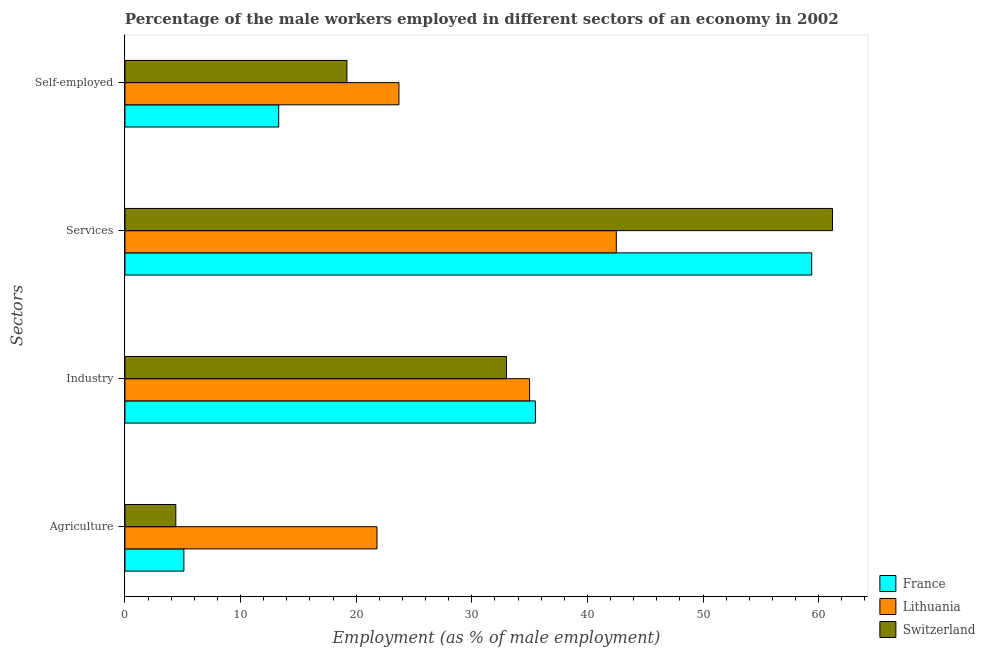How many different coloured bars are there?
Your answer should be very brief. 3. How many groups of bars are there?
Provide a short and direct response. 4. Are the number of bars per tick equal to the number of legend labels?
Keep it short and to the point. Yes. How many bars are there on the 4th tick from the top?
Offer a terse response. 3. How many bars are there on the 1st tick from the bottom?
Provide a succinct answer. 3. What is the label of the 2nd group of bars from the top?
Offer a very short reply. Services. Across all countries, what is the maximum percentage of male workers in services?
Ensure brevity in your answer.  61.2. Across all countries, what is the minimum percentage of male workers in industry?
Your answer should be very brief. 33. In which country was the percentage of male workers in industry maximum?
Make the answer very short. France. In which country was the percentage of male workers in agriculture minimum?
Ensure brevity in your answer.  Switzerland. What is the total percentage of self employed male workers in the graph?
Your answer should be compact. 56.2. What is the difference between the percentage of male workers in agriculture in France and that in Lithuania?
Your response must be concise. -16.7. What is the difference between the percentage of male workers in services in Lithuania and the percentage of self employed male workers in France?
Your answer should be very brief. 29.2. What is the average percentage of self employed male workers per country?
Provide a succinct answer. 18.73. What is the difference between the percentage of male workers in services and percentage of male workers in industry in France?
Make the answer very short. 23.9. What is the ratio of the percentage of self employed male workers in France to that in Switzerland?
Your response must be concise. 0.69. Is the percentage of self employed male workers in Switzerland less than that in France?
Make the answer very short. No. What is the difference between the highest and the second highest percentage of self employed male workers?
Your answer should be compact. 4.5. What is the difference between the highest and the lowest percentage of male workers in agriculture?
Provide a succinct answer. 17.4. In how many countries, is the percentage of male workers in services greater than the average percentage of male workers in services taken over all countries?
Make the answer very short. 2. Is the sum of the percentage of self employed male workers in Switzerland and France greater than the maximum percentage of male workers in industry across all countries?
Ensure brevity in your answer.  No. Is it the case that in every country, the sum of the percentage of self employed male workers and percentage of male workers in agriculture is greater than the sum of percentage of male workers in services and percentage of male workers in industry?
Offer a terse response. No. What does the 2nd bar from the top in Self-employed represents?
Give a very brief answer. Lithuania. How many bars are there?
Offer a terse response. 12. Are all the bars in the graph horizontal?
Keep it short and to the point. Yes. Does the graph contain grids?
Ensure brevity in your answer.  No. Where does the legend appear in the graph?
Offer a very short reply. Bottom right. How many legend labels are there?
Your answer should be very brief. 3. How are the legend labels stacked?
Ensure brevity in your answer.  Vertical. What is the title of the graph?
Your answer should be very brief. Percentage of the male workers employed in different sectors of an economy in 2002. Does "Lower middle income" appear as one of the legend labels in the graph?
Provide a succinct answer. No. What is the label or title of the X-axis?
Your response must be concise. Employment (as % of male employment). What is the label or title of the Y-axis?
Give a very brief answer. Sectors. What is the Employment (as % of male employment) in France in Agriculture?
Your answer should be compact. 5.1. What is the Employment (as % of male employment) in Lithuania in Agriculture?
Provide a short and direct response. 21.8. What is the Employment (as % of male employment) in Switzerland in Agriculture?
Your response must be concise. 4.4. What is the Employment (as % of male employment) of France in Industry?
Give a very brief answer. 35.5. What is the Employment (as % of male employment) of Lithuania in Industry?
Ensure brevity in your answer.  35. What is the Employment (as % of male employment) of France in Services?
Make the answer very short. 59.4. What is the Employment (as % of male employment) of Lithuania in Services?
Your answer should be compact. 42.5. What is the Employment (as % of male employment) in Switzerland in Services?
Offer a very short reply. 61.2. What is the Employment (as % of male employment) of France in Self-employed?
Offer a very short reply. 13.3. What is the Employment (as % of male employment) in Lithuania in Self-employed?
Offer a very short reply. 23.7. What is the Employment (as % of male employment) in Switzerland in Self-employed?
Ensure brevity in your answer.  19.2. Across all Sectors, what is the maximum Employment (as % of male employment) of France?
Provide a succinct answer. 59.4. Across all Sectors, what is the maximum Employment (as % of male employment) in Lithuania?
Your answer should be compact. 42.5. Across all Sectors, what is the maximum Employment (as % of male employment) in Switzerland?
Ensure brevity in your answer.  61.2. Across all Sectors, what is the minimum Employment (as % of male employment) in France?
Ensure brevity in your answer.  5.1. Across all Sectors, what is the minimum Employment (as % of male employment) in Lithuania?
Provide a short and direct response. 21.8. Across all Sectors, what is the minimum Employment (as % of male employment) of Switzerland?
Make the answer very short. 4.4. What is the total Employment (as % of male employment) in France in the graph?
Provide a short and direct response. 113.3. What is the total Employment (as % of male employment) of Lithuania in the graph?
Your answer should be compact. 123. What is the total Employment (as % of male employment) in Switzerland in the graph?
Ensure brevity in your answer.  117.8. What is the difference between the Employment (as % of male employment) of France in Agriculture and that in Industry?
Ensure brevity in your answer.  -30.4. What is the difference between the Employment (as % of male employment) in Lithuania in Agriculture and that in Industry?
Your response must be concise. -13.2. What is the difference between the Employment (as % of male employment) in Switzerland in Agriculture and that in Industry?
Provide a succinct answer. -28.6. What is the difference between the Employment (as % of male employment) of France in Agriculture and that in Services?
Your answer should be very brief. -54.3. What is the difference between the Employment (as % of male employment) in Lithuania in Agriculture and that in Services?
Your answer should be compact. -20.7. What is the difference between the Employment (as % of male employment) of Switzerland in Agriculture and that in Services?
Keep it short and to the point. -56.8. What is the difference between the Employment (as % of male employment) in France in Agriculture and that in Self-employed?
Provide a succinct answer. -8.2. What is the difference between the Employment (as % of male employment) of Lithuania in Agriculture and that in Self-employed?
Offer a very short reply. -1.9. What is the difference between the Employment (as % of male employment) in Switzerland in Agriculture and that in Self-employed?
Provide a short and direct response. -14.8. What is the difference between the Employment (as % of male employment) of France in Industry and that in Services?
Offer a terse response. -23.9. What is the difference between the Employment (as % of male employment) of Switzerland in Industry and that in Services?
Your response must be concise. -28.2. What is the difference between the Employment (as % of male employment) in Lithuania in Industry and that in Self-employed?
Your response must be concise. 11.3. What is the difference between the Employment (as % of male employment) of Switzerland in Industry and that in Self-employed?
Ensure brevity in your answer.  13.8. What is the difference between the Employment (as % of male employment) of France in Services and that in Self-employed?
Keep it short and to the point. 46.1. What is the difference between the Employment (as % of male employment) in France in Agriculture and the Employment (as % of male employment) in Lithuania in Industry?
Your answer should be very brief. -29.9. What is the difference between the Employment (as % of male employment) of France in Agriculture and the Employment (as % of male employment) of Switzerland in Industry?
Offer a terse response. -27.9. What is the difference between the Employment (as % of male employment) in France in Agriculture and the Employment (as % of male employment) in Lithuania in Services?
Your answer should be very brief. -37.4. What is the difference between the Employment (as % of male employment) of France in Agriculture and the Employment (as % of male employment) of Switzerland in Services?
Provide a short and direct response. -56.1. What is the difference between the Employment (as % of male employment) in Lithuania in Agriculture and the Employment (as % of male employment) in Switzerland in Services?
Your answer should be very brief. -39.4. What is the difference between the Employment (as % of male employment) in France in Agriculture and the Employment (as % of male employment) in Lithuania in Self-employed?
Your response must be concise. -18.6. What is the difference between the Employment (as % of male employment) of France in Agriculture and the Employment (as % of male employment) of Switzerland in Self-employed?
Offer a very short reply. -14.1. What is the difference between the Employment (as % of male employment) of France in Industry and the Employment (as % of male employment) of Lithuania in Services?
Provide a short and direct response. -7. What is the difference between the Employment (as % of male employment) of France in Industry and the Employment (as % of male employment) of Switzerland in Services?
Provide a succinct answer. -25.7. What is the difference between the Employment (as % of male employment) in Lithuania in Industry and the Employment (as % of male employment) in Switzerland in Services?
Your response must be concise. -26.2. What is the difference between the Employment (as % of male employment) of France in Industry and the Employment (as % of male employment) of Lithuania in Self-employed?
Your response must be concise. 11.8. What is the difference between the Employment (as % of male employment) of France in Industry and the Employment (as % of male employment) of Switzerland in Self-employed?
Your answer should be very brief. 16.3. What is the difference between the Employment (as % of male employment) in Lithuania in Industry and the Employment (as % of male employment) in Switzerland in Self-employed?
Offer a very short reply. 15.8. What is the difference between the Employment (as % of male employment) in France in Services and the Employment (as % of male employment) in Lithuania in Self-employed?
Keep it short and to the point. 35.7. What is the difference between the Employment (as % of male employment) in France in Services and the Employment (as % of male employment) in Switzerland in Self-employed?
Give a very brief answer. 40.2. What is the difference between the Employment (as % of male employment) in Lithuania in Services and the Employment (as % of male employment) in Switzerland in Self-employed?
Make the answer very short. 23.3. What is the average Employment (as % of male employment) in France per Sectors?
Offer a terse response. 28.32. What is the average Employment (as % of male employment) of Lithuania per Sectors?
Keep it short and to the point. 30.75. What is the average Employment (as % of male employment) of Switzerland per Sectors?
Offer a very short reply. 29.45. What is the difference between the Employment (as % of male employment) in France and Employment (as % of male employment) in Lithuania in Agriculture?
Offer a very short reply. -16.7. What is the difference between the Employment (as % of male employment) of France and Employment (as % of male employment) of Switzerland in Agriculture?
Provide a succinct answer. 0.7. What is the difference between the Employment (as % of male employment) of Lithuania and Employment (as % of male employment) of Switzerland in Agriculture?
Provide a succinct answer. 17.4. What is the difference between the Employment (as % of male employment) of France and Employment (as % of male employment) of Lithuania in Industry?
Offer a very short reply. 0.5. What is the difference between the Employment (as % of male employment) of France and Employment (as % of male employment) of Lithuania in Services?
Your answer should be very brief. 16.9. What is the difference between the Employment (as % of male employment) of France and Employment (as % of male employment) of Switzerland in Services?
Provide a succinct answer. -1.8. What is the difference between the Employment (as % of male employment) in Lithuania and Employment (as % of male employment) in Switzerland in Services?
Give a very brief answer. -18.7. What is the difference between the Employment (as % of male employment) of France and Employment (as % of male employment) of Lithuania in Self-employed?
Offer a very short reply. -10.4. What is the ratio of the Employment (as % of male employment) of France in Agriculture to that in Industry?
Offer a very short reply. 0.14. What is the ratio of the Employment (as % of male employment) of Lithuania in Agriculture to that in Industry?
Your answer should be compact. 0.62. What is the ratio of the Employment (as % of male employment) in Switzerland in Agriculture to that in Industry?
Your answer should be compact. 0.13. What is the ratio of the Employment (as % of male employment) of France in Agriculture to that in Services?
Your response must be concise. 0.09. What is the ratio of the Employment (as % of male employment) in Lithuania in Agriculture to that in Services?
Ensure brevity in your answer.  0.51. What is the ratio of the Employment (as % of male employment) of Switzerland in Agriculture to that in Services?
Give a very brief answer. 0.07. What is the ratio of the Employment (as % of male employment) of France in Agriculture to that in Self-employed?
Ensure brevity in your answer.  0.38. What is the ratio of the Employment (as % of male employment) in Lithuania in Agriculture to that in Self-employed?
Your answer should be very brief. 0.92. What is the ratio of the Employment (as % of male employment) in Switzerland in Agriculture to that in Self-employed?
Provide a succinct answer. 0.23. What is the ratio of the Employment (as % of male employment) of France in Industry to that in Services?
Provide a succinct answer. 0.6. What is the ratio of the Employment (as % of male employment) of Lithuania in Industry to that in Services?
Provide a succinct answer. 0.82. What is the ratio of the Employment (as % of male employment) of Switzerland in Industry to that in Services?
Provide a short and direct response. 0.54. What is the ratio of the Employment (as % of male employment) of France in Industry to that in Self-employed?
Your answer should be very brief. 2.67. What is the ratio of the Employment (as % of male employment) in Lithuania in Industry to that in Self-employed?
Make the answer very short. 1.48. What is the ratio of the Employment (as % of male employment) in Switzerland in Industry to that in Self-employed?
Make the answer very short. 1.72. What is the ratio of the Employment (as % of male employment) in France in Services to that in Self-employed?
Make the answer very short. 4.47. What is the ratio of the Employment (as % of male employment) of Lithuania in Services to that in Self-employed?
Keep it short and to the point. 1.79. What is the ratio of the Employment (as % of male employment) in Switzerland in Services to that in Self-employed?
Make the answer very short. 3.19. What is the difference between the highest and the second highest Employment (as % of male employment) in France?
Make the answer very short. 23.9. What is the difference between the highest and the second highest Employment (as % of male employment) of Switzerland?
Keep it short and to the point. 28.2. What is the difference between the highest and the lowest Employment (as % of male employment) of France?
Your response must be concise. 54.3. What is the difference between the highest and the lowest Employment (as % of male employment) in Lithuania?
Your response must be concise. 20.7. What is the difference between the highest and the lowest Employment (as % of male employment) in Switzerland?
Your answer should be very brief. 56.8. 